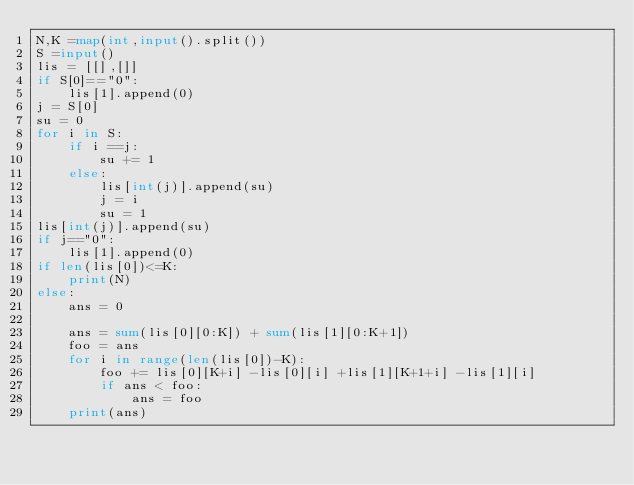Convert code to text. <code><loc_0><loc_0><loc_500><loc_500><_Python_>N,K =map(int,input().split())
S =input()
lis = [[],[]]
if S[0]=="0":
    lis[1].append(0)
j = S[0]
su = 0
for i in S:
    if i ==j:
        su += 1
    else:
        lis[int(j)].append(su)
        j = i
        su = 1
lis[int(j)].append(su)
if j=="0":
    lis[1].append(0)
if len(lis[0])<=K:
    print(N)
else:
    ans = 0

    ans = sum(lis[0][0:K]) + sum(lis[1][0:K+1])
    foo = ans
    for i in range(len(lis[0])-K):
        foo += lis[0][K+i] -lis[0][i] +lis[1][K+1+i] -lis[1][i]
        if ans < foo:
            ans = foo
    print(ans)
</code> 